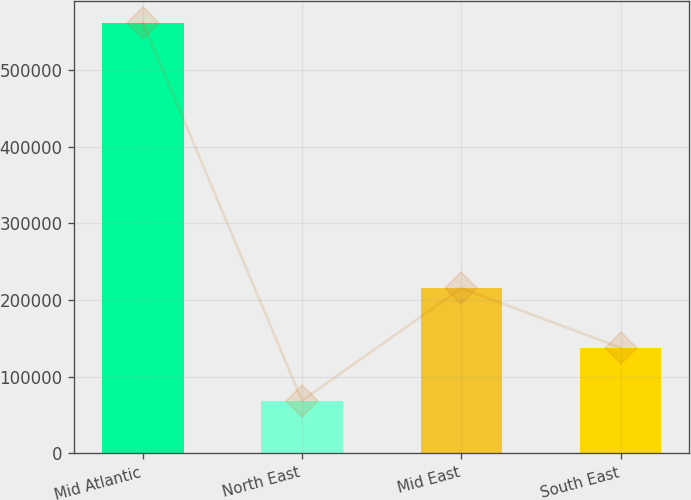Convert chart. <chart><loc_0><loc_0><loc_500><loc_500><bar_chart><fcel>Mid Atlantic<fcel>North East<fcel>Mid East<fcel>South East<nl><fcel>561857<fcel>68808<fcel>215335<fcel>137787<nl></chart> 